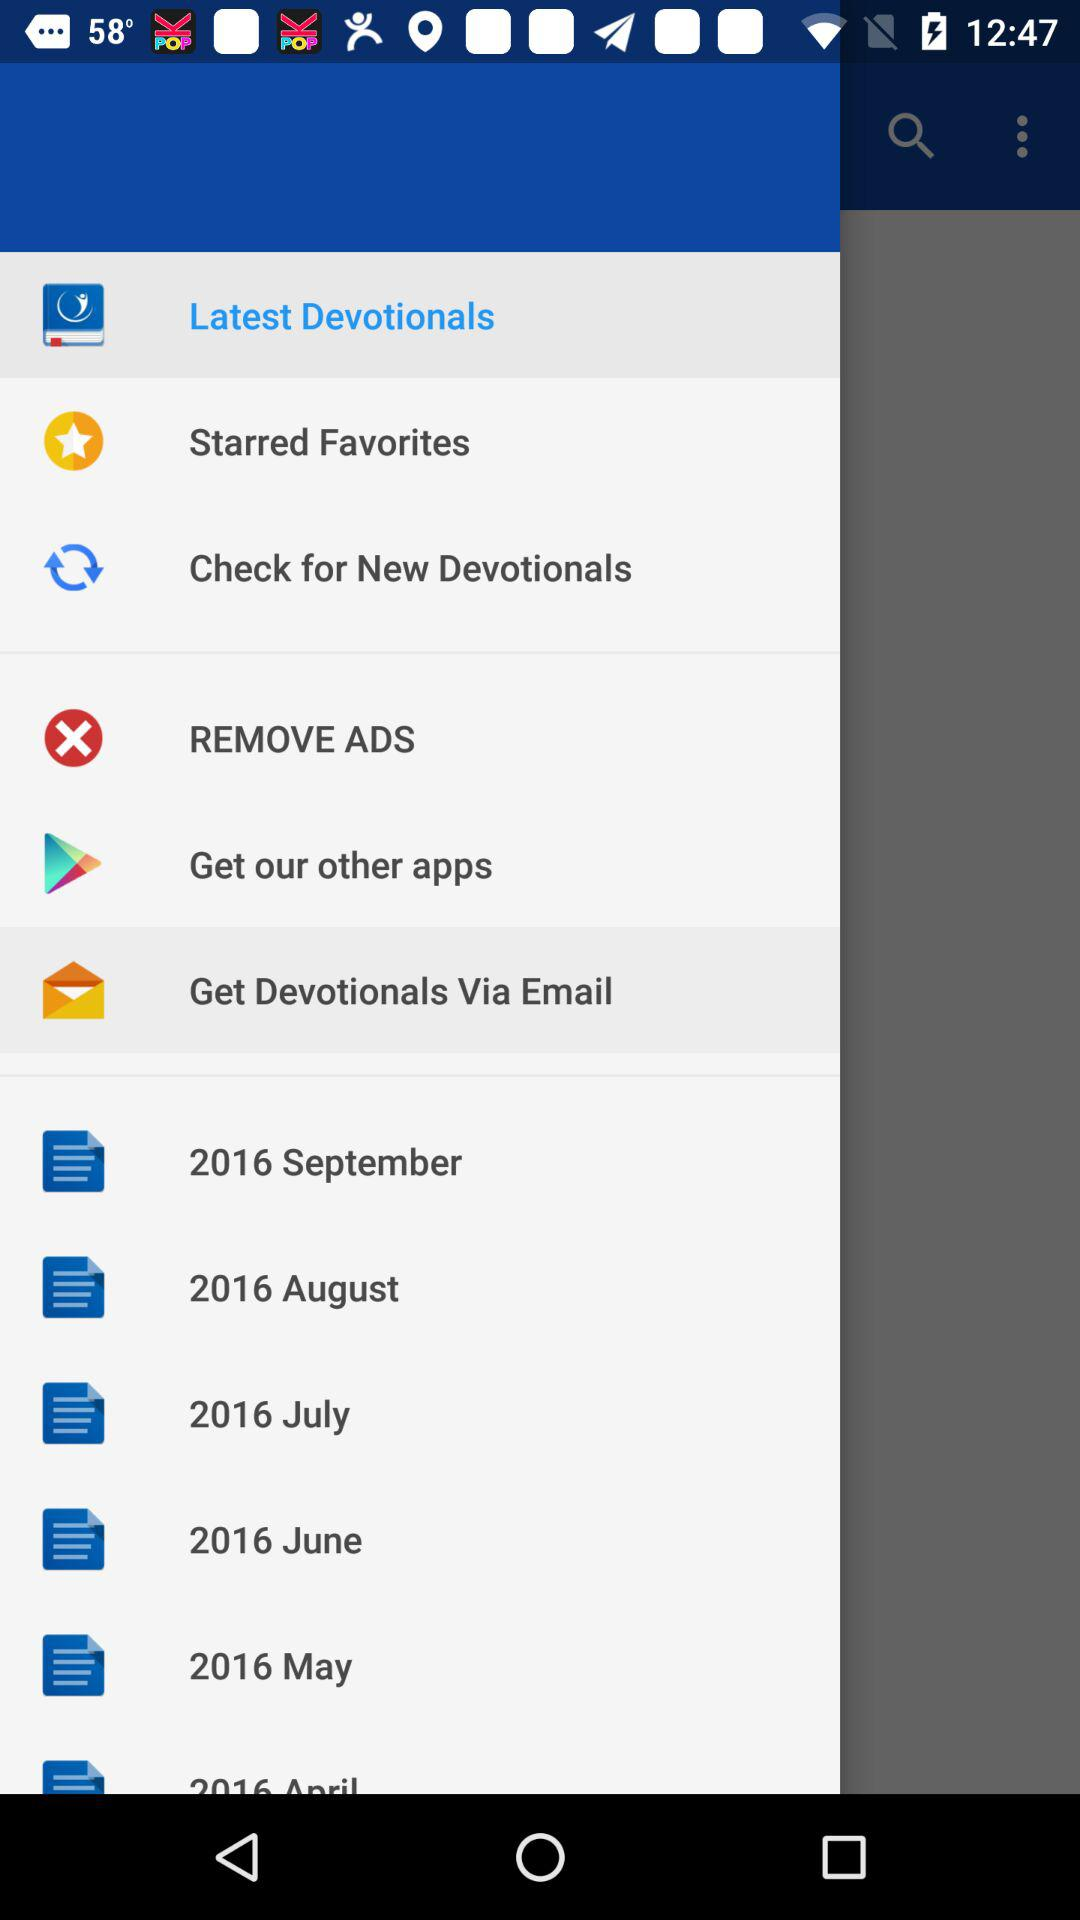How many of the devotionals are in the year 2016?
Answer the question using a single word or phrase. 6 